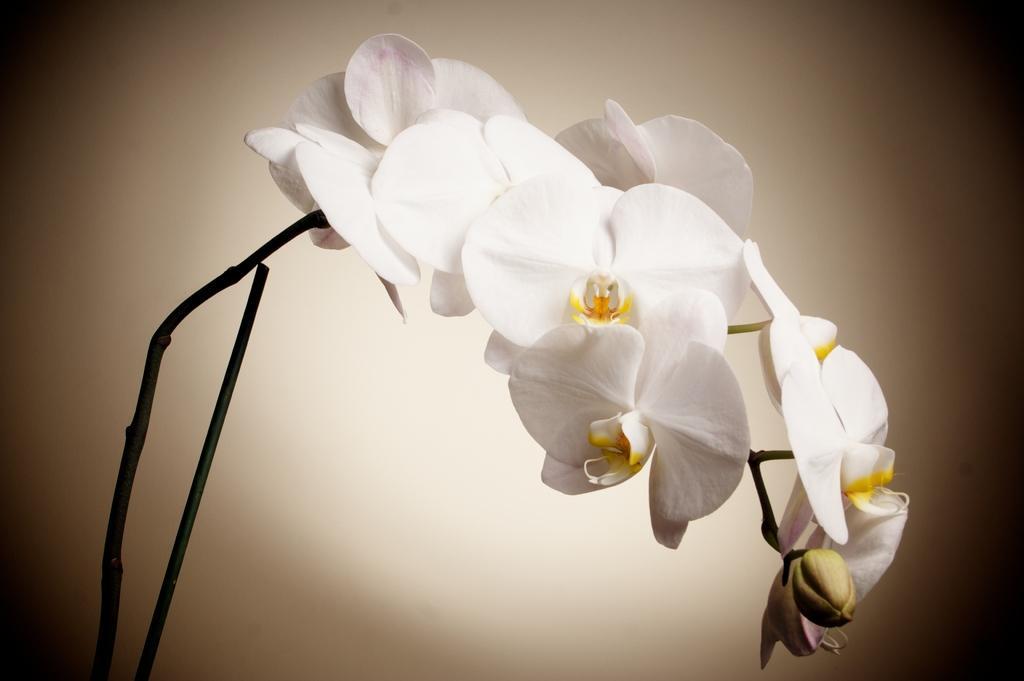Please provide a concise description of this image. In this image there are white flowers, there is a bud, there are stems truncated towards the bottom of the image, the background of the image is white in color. 